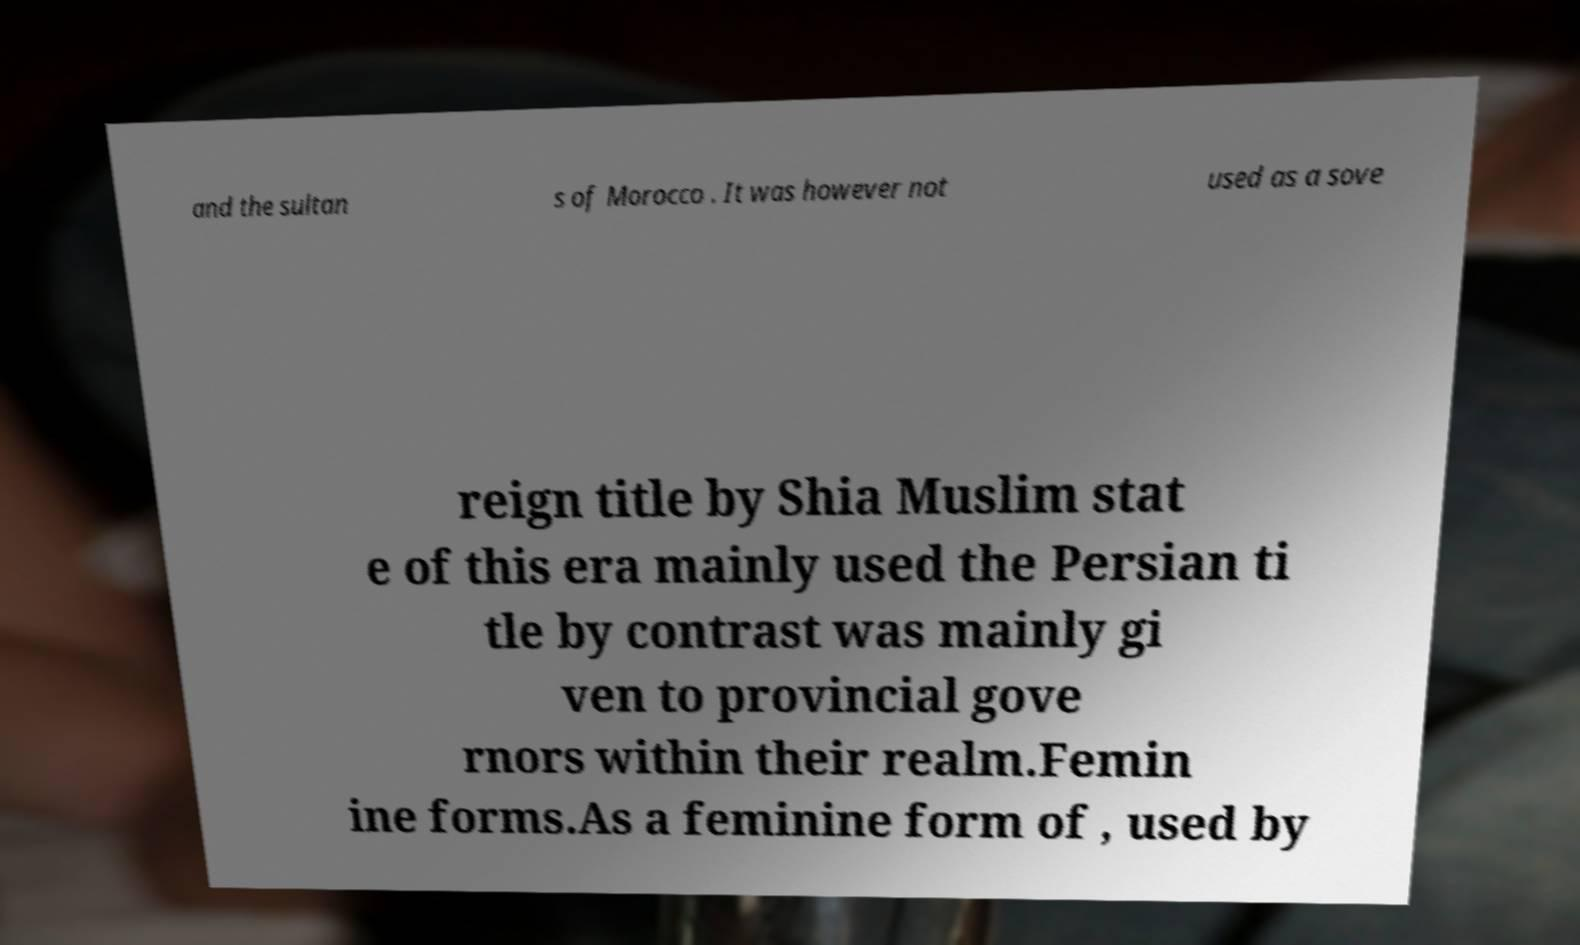For documentation purposes, I need the text within this image transcribed. Could you provide that? and the sultan s of Morocco . It was however not used as a sove reign title by Shia Muslim stat e of this era mainly used the Persian ti tle by contrast was mainly gi ven to provincial gove rnors within their realm.Femin ine forms.As a feminine form of , used by 